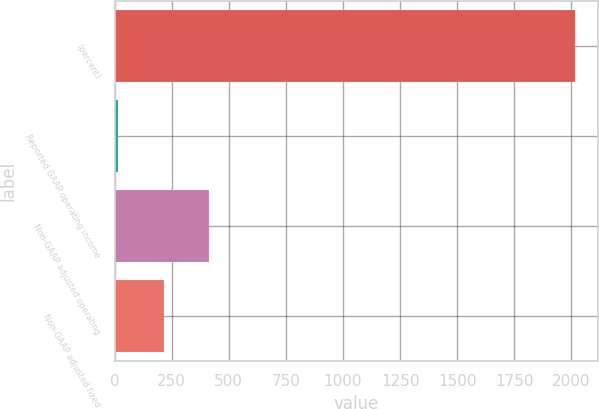Convert chart to OTSL. <chart><loc_0><loc_0><loc_500><loc_500><bar_chart><fcel>(percent)<fcel>Reported GAAP operating income<fcel>Non-GAAP adjusted operating<fcel>Non-GAAP adjusted fixed<nl><fcel>2016<fcel>14.6<fcel>414.88<fcel>214.74<nl></chart> 